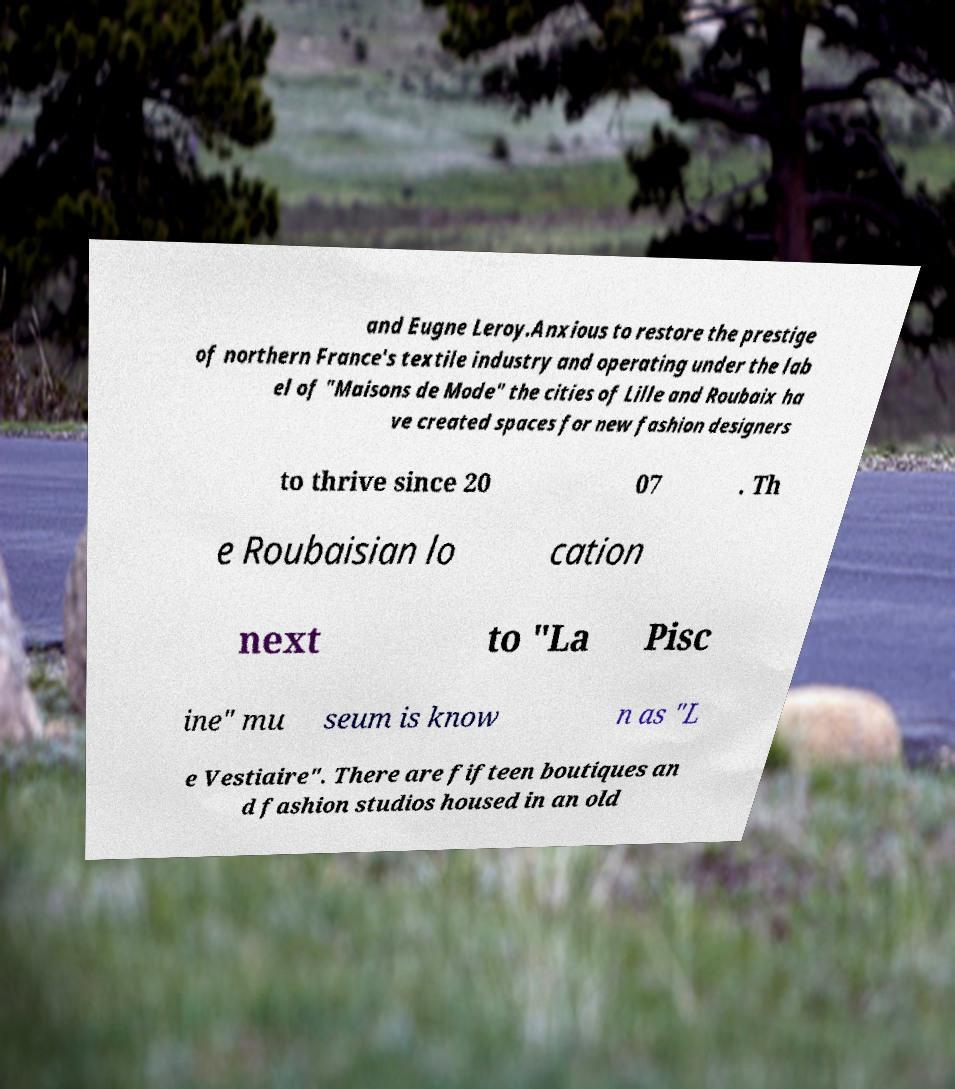Please identify and transcribe the text found in this image. and Eugne Leroy.Anxious to restore the prestige of northern France's textile industry and operating under the lab el of "Maisons de Mode" the cities of Lille and Roubaix ha ve created spaces for new fashion designers to thrive since 20 07 . Th e Roubaisian lo cation next to "La Pisc ine" mu seum is know n as "L e Vestiaire". There are fifteen boutiques an d fashion studios housed in an old 